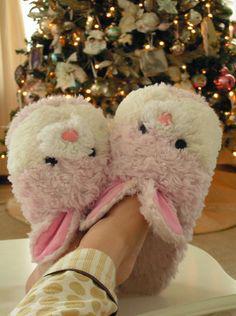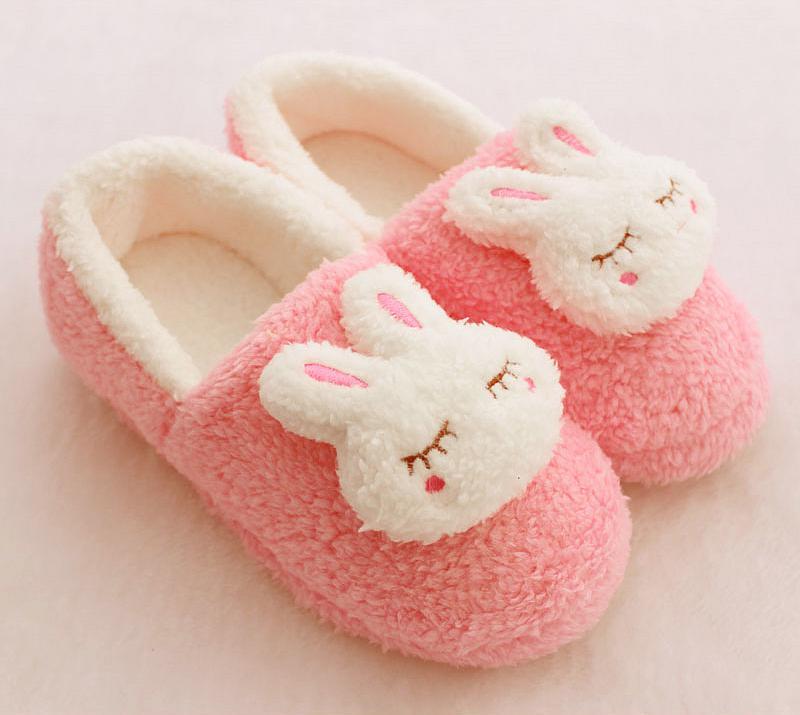The first image is the image on the left, the second image is the image on the right. For the images displayed, is the sentence "there are two pair of punny slippers in the image pair" factually correct? Answer yes or no. Yes. 